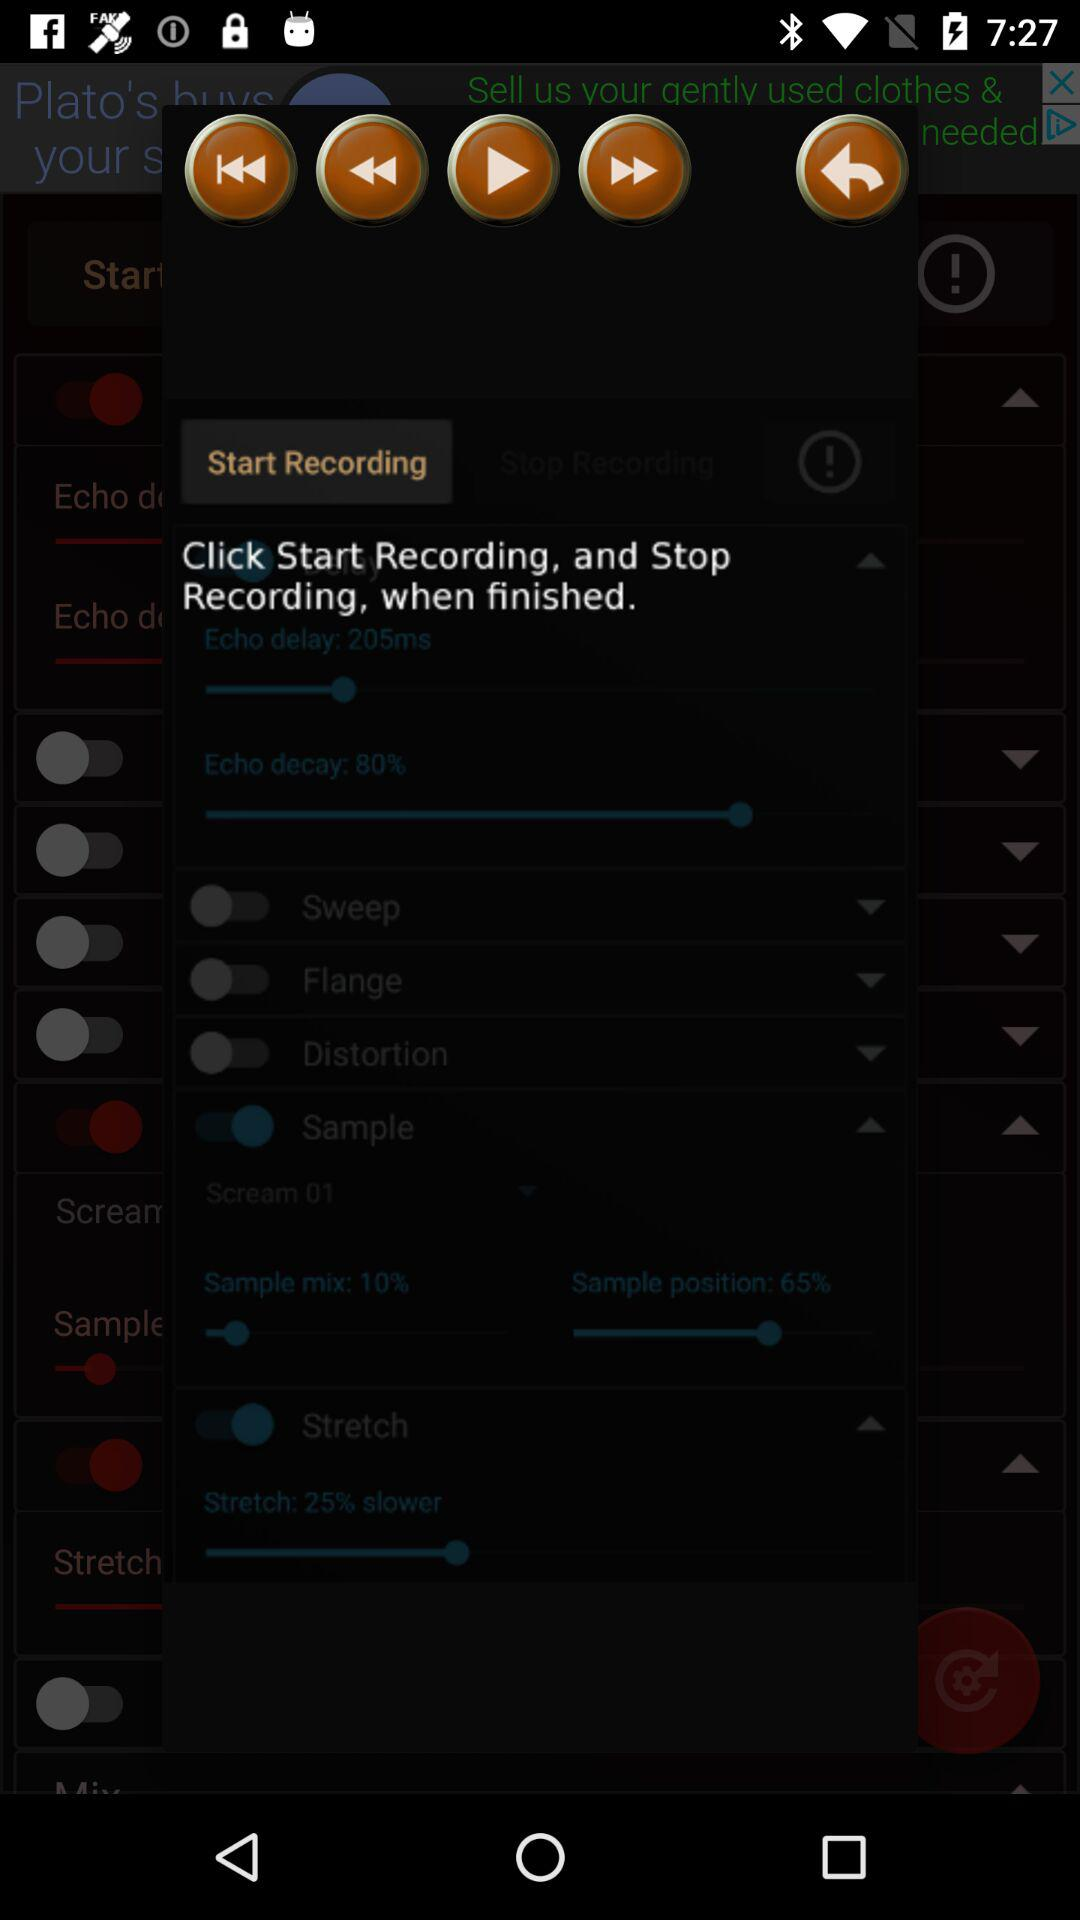What is the time duration of echo delay?
When the provided information is insufficient, respond with <no answer>. <no answer> 